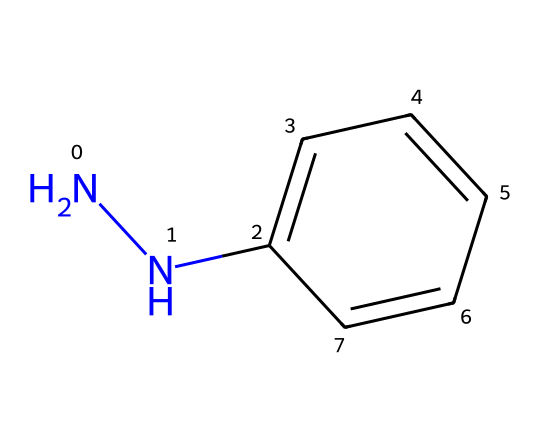What is the molecular formula of phenylhydrazine? The molecular formula can be derived from the SMILES representation. Counting the atoms, there are 6 carbon atoms (c1ccccc1), 7 hydrogen atoms (from both the aromatic ring and the hydrazine group), and 2 nitrogen atoms (NN). Thus, the molecular formula is C6H8N2.
Answer: C6H8N2 How many rings are present in this structure? In the SMILES provided, the 'c' indicates the presence of a carbon ring in the benzene part of phenylhydrazine. The structure exhibits one aromatic ring (the phenyl part). Therefore, there is one ring present.
Answer: 1 What type of functional group is present in phenylhydrazine? The functional group is identifiable by the 'NN' seen in the SMILES, indicating the presence of a hydrazone functional group. This characterizes phenylhydrazine as a hydrazine derivative.
Answer: hydrazine What is the total number of nitrogen atoms in phenylhydrazine? The SMILES notation 'NN' indicates that there are two nitrogen atoms in the structure, which are part of the hydrazine moiety. Thus, the total count is two nitrogen atoms.
Answer: 2 Why does phenylhydrazine have potential use in polymerization processes? The nitrogen atoms in the hydrazine group contribute to nucleophilicity, which can participate in polymerization reactions, making phenylhydrazine useful in creating crosslinked polymers. Additionally, the benzene ring can facilitate further reactions.
Answer: nucleophilicity What is the hybridization of the nitrogen atoms in phenylhydrazine? Each nitrogen atom in the hydrazine group is bonded to two other atoms (one hydrogen and one nitrogen), which means they adopt a sp2 hybridization to maintain a planar geometry with some degree of lone pair repulsion.
Answer: sp2 